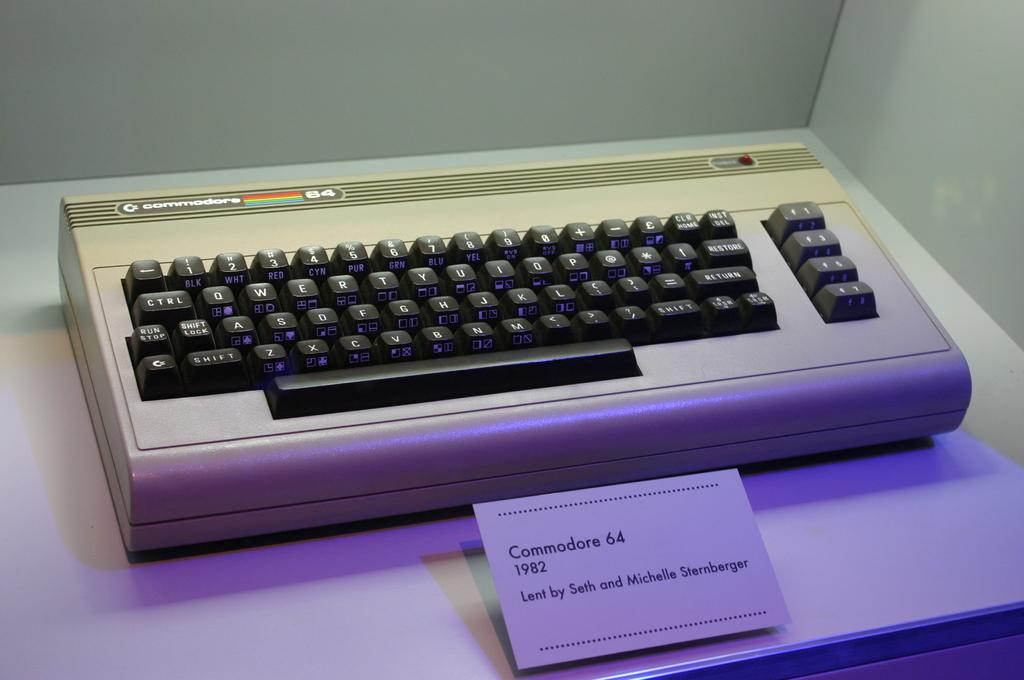<image>
Share a concise interpretation of the image provided. Commodore 64 1982 on the table was lent by Seth and Michelle Sternberger 